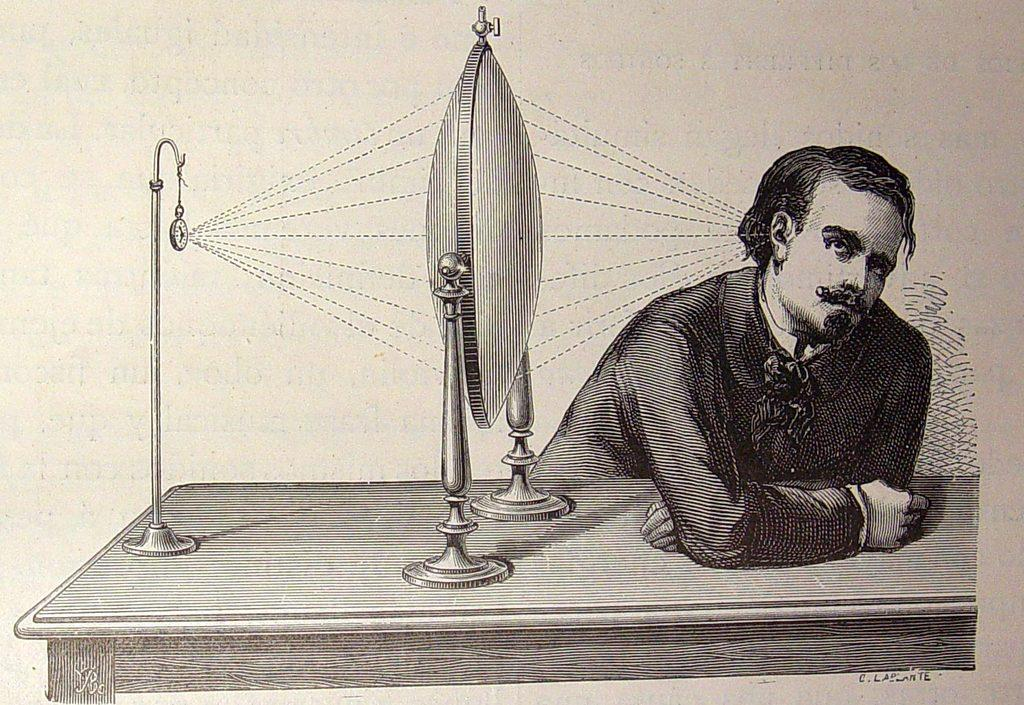Who is present in the image? There is a man in the image. Where is the man located in the image? The man is on the right side of the image. What type of furniture is in the image? There is a wooden table in the image. What is on top of the wooden table? Waves traveling machine equipment is present on the wooden table. What type of cover is the man using to protect himself from the protest in the image? There is no mention of a protest or a cover in the image; it only features a man, a wooden table, and waves traveling machine equipment. 